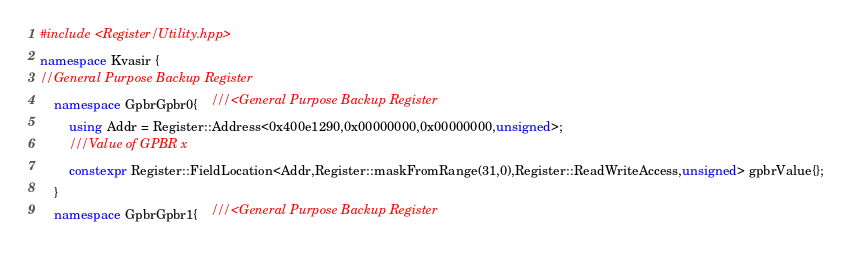<code> <loc_0><loc_0><loc_500><loc_500><_C++_>#include <Register/Utility.hpp>
namespace Kvasir {
//General Purpose Backup Register
    namespace GpbrGpbr0{    ///<General Purpose Backup Register
        using Addr = Register::Address<0x400e1290,0x00000000,0x00000000,unsigned>;
        ///Value of GPBR x
        constexpr Register::FieldLocation<Addr,Register::maskFromRange(31,0),Register::ReadWriteAccess,unsigned> gpbrValue{}; 
    }
    namespace GpbrGpbr1{    ///<General Purpose Backup Register</code> 